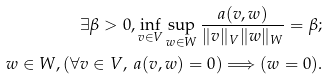Convert formula to latex. <formula><loc_0><loc_0><loc_500><loc_500>\exists \beta > 0 , \inf _ { v \in V } \sup _ { w \in W } \frac { a ( v , w ) } { \| v \| _ { V } \| w \| _ { W } } = \beta ; \\ w \in W , ( \forall v \in V , \ a ( v , w ) = 0 ) \Longrightarrow ( w = 0 ) .</formula> 